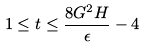Convert formula to latex. <formula><loc_0><loc_0><loc_500><loc_500>1 \leq t \leq \frac { 8 G ^ { 2 } H } { \epsilon } - 4</formula> 